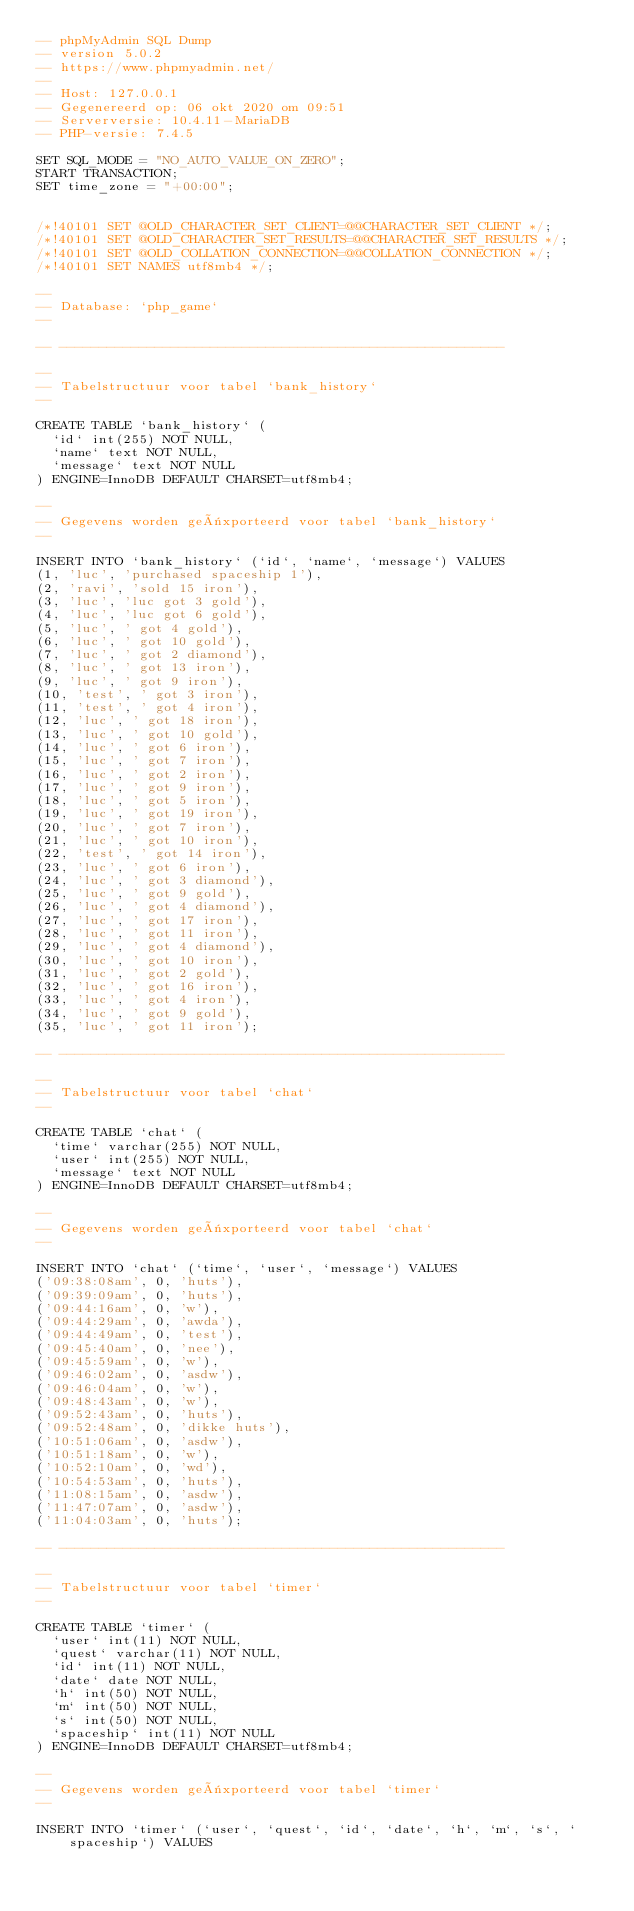<code> <loc_0><loc_0><loc_500><loc_500><_SQL_>-- phpMyAdmin SQL Dump
-- version 5.0.2
-- https://www.phpmyadmin.net/
--
-- Host: 127.0.0.1
-- Gegenereerd op: 06 okt 2020 om 09:51
-- Serverversie: 10.4.11-MariaDB
-- PHP-versie: 7.4.5

SET SQL_MODE = "NO_AUTO_VALUE_ON_ZERO";
START TRANSACTION;
SET time_zone = "+00:00";


/*!40101 SET @OLD_CHARACTER_SET_CLIENT=@@CHARACTER_SET_CLIENT */;
/*!40101 SET @OLD_CHARACTER_SET_RESULTS=@@CHARACTER_SET_RESULTS */;
/*!40101 SET @OLD_COLLATION_CONNECTION=@@COLLATION_CONNECTION */;
/*!40101 SET NAMES utf8mb4 */;

--
-- Database: `php_game`
--

-- --------------------------------------------------------

--
-- Tabelstructuur voor tabel `bank_history`
--

CREATE TABLE `bank_history` (
  `id` int(255) NOT NULL,
  `name` text NOT NULL,
  `message` text NOT NULL
) ENGINE=InnoDB DEFAULT CHARSET=utf8mb4;

--
-- Gegevens worden geëxporteerd voor tabel `bank_history`
--

INSERT INTO `bank_history` (`id`, `name`, `message`) VALUES
(1, 'luc', 'purchased spaceship 1'),
(2, 'ravi', 'sold 15 iron'),
(3, 'luc', 'luc got 3 gold'),
(4, 'luc', 'luc got 6 gold'),
(5, 'luc', ' got 4 gold'),
(6, 'luc', ' got 10 gold'),
(7, 'luc', ' got 2 diamond'),
(8, 'luc', ' got 13 iron'),
(9, 'luc', ' got 9 iron'),
(10, 'test', ' got 3 iron'),
(11, 'test', ' got 4 iron'),
(12, 'luc', ' got 18 iron'),
(13, 'luc', ' got 10 gold'),
(14, 'luc', ' got 6 iron'),
(15, 'luc', ' got 7 iron'),
(16, 'luc', ' got 2 iron'),
(17, 'luc', ' got 9 iron'),
(18, 'luc', ' got 5 iron'),
(19, 'luc', ' got 19 iron'),
(20, 'luc', ' got 7 iron'),
(21, 'luc', ' got 10 iron'),
(22, 'test', ' got 14 iron'),
(23, 'luc', ' got 6 iron'),
(24, 'luc', ' got 3 diamond'),
(25, 'luc', ' got 9 gold'),
(26, 'luc', ' got 4 diamond'),
(27, 'luc', ' got 17 iron'),
(28, 'luc', ' got 11 iron'),
(29, 'luc', ' got 4 diamond'),
(30, 'luc', ' got 10 iron'),
(31, 'luc', ' got 2 gold'),
(32, 'luc', ' got 16 iron'),
(33, 'luc', ' got 4 iron'),
(34, 'luc', ' got 9 gold'),
(35, 'luc', ' got 11 iron');

-- --------------------------------------------------------

--
-- Tabelstructuur voor tabel `chat`
--

CREATE TABLE `chat` (
  `time` varchar(255) NOT NULL,
  `user` int(255) NOT NULL,
  `message` text NOT NULL
) ENGINE=InnoDB DEFAULT CHARSET=utf8mb4;

--
-- Gegevens worden geëxporteerd voor tabel `chat`
--

INSERT INTO `chat` (`time`, `user`, `message`) VALUES
('09:38:08am', 0, 'huts'),
('09:39:09am', 0, 'huts'),
('09:44:16am', 0, 'w'),
('09:44:29am', 0, 'awda'),
('09:44:49am', 0, 'test'),
('09:45:40am', 0, 'nee'),
('09:45:59am', 0, 'w'),
('09:46:02am', 0, 'asdw'),
('09:46:04am', 0, 'w'),
('09:48:43am', 0, 'w'),
('09:52:43am', 0, 'huts'),
('09:52:48am', 0, 'dikke huts'),
('10:51:06am', 0, 'asdw'),
('10:51:18am', 0, 'w'),
('10:52:10am', 0, 'wd'),
('10:54:53am', 0, 'huts'),
('11:08:15am', 0, 'asdw'),
('11:47:07am', 0, 'asdw'),
('11:04:03am', 0, 'huts');

-- --------------------------------------------------------

--
-- Tabelstructuur voor tabel `timer`
--

CREATE TABLE `timer` (
  `user` int(11) NOT NULL,
  `quest` varchar(11) NOT NULL,
  `id` int(11) NOT NULL,
  `date` date NOT NULL,
  `h` int(50) NOT NULL,
  `m` int(50) NOT NULL,
  `s` int(50) NOT NULL,
  `spaceship` int(11) NOT NULL
) ENGINE=InnoDB DEFAULT CHARSET=utf8mb4;

--
-- Gegevens worden geëxporteerd voor tabel `timer`
--

INSERT INTO `timer` (`user`, `quest`, `id`, `date`, `h`, `m`, `s`, `spaceship`) VALUES</code> 